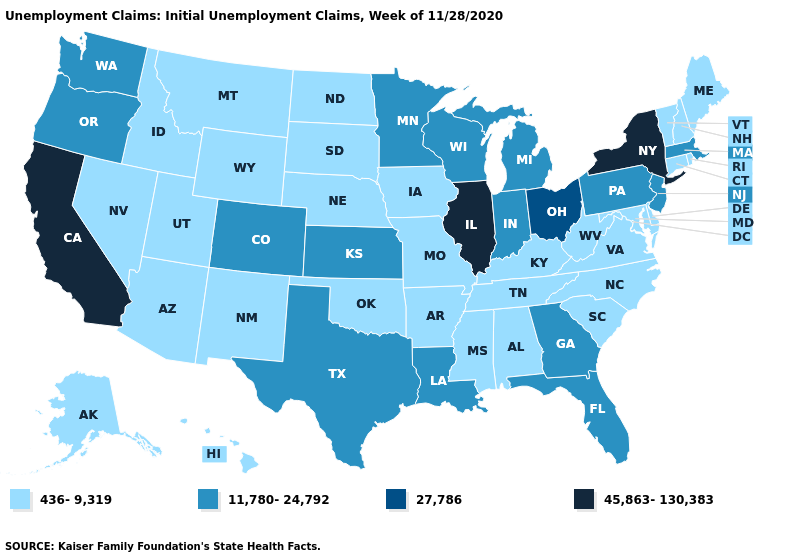Name the states that have a value in the range 27,786?
Write a very short answer. Ohio. Among the states that border North Carolina , which have the lowest value?
Keep it brief. South Carolina, Tennessee, Virginia. Name the states that have a value in the range 11,780-24,792?
Quick response, please. Colorado, Florida, Georgia, Indiana, Kansas, Louisiana, Massachusetts, Michigan, Minnesota, New Jersey, Oregon, Pennsylvania, Texas, Washington, Wisconsin. What is the value of Wyoming?
Concise answer only. 436-9,319. What is the value of Illinois?
Answer briefly. 45,863-130,383. What is the value of South Dakota?
Concise answer only. 436-9,319. Name the states that have a value in the range 11,780-24,792?
Be succinct. Colorado, Florida, Georgia, Indiana, Kansas, Louisiana, Massachusetts, Michigan, Minnesota, New Jersey, Oregon, Pennsylvania, Texas, Washington, Wisconsin. What is the highest value in the Northeast ?
Be succinct. 45,863-130,383. Does California have the highest value in the USA?
Keep it brief. Yes. How many symbols are there in the legend?
Short answer required. 4. What is the lowest value in the USA?
Give a very brief answer. 436-9,319. Name the states that have a value in the range 11,780-24,792?
Write a very short answer. Colorado, Florida, Georgia, Indiana, Kansas, Louisiana, Massachusetts, Michigan, Minnesota, New Jersey, Oregon, Pennsylvania, Texas, Washington, Wisconsin. Does New York have the highest value in the USA?
Answer briefly. Yes. Name the states that have a value in the range 11,780-24,792?
Give a very brief answer. Colorado, Florida, Georgia, Indiana, Kansas, Louisiana, Massachusetts, Michigan, Minnesota, New Jersey, Oregon, Pennsylvania, Texas, Washington, Wisconsin. Name the states that have a value in the range 436-9,319?
Concise answer only. Alabama, Alaska, Arizona, Arkansas, Connecticut, Delaware, Hawaii, Idaho, Iowa, Kentucky, Maine, Maryland, Mississippi, Missouri, Montana, Nebraska, Nevada, New Hampshire, New Mexico, North Carolina, North Dakota, Oklahoma, Rhode Island, South Carolina, South Dakota, Tennessee, Utah, Vermont, Virginia, West Virginia, Wyoming. 